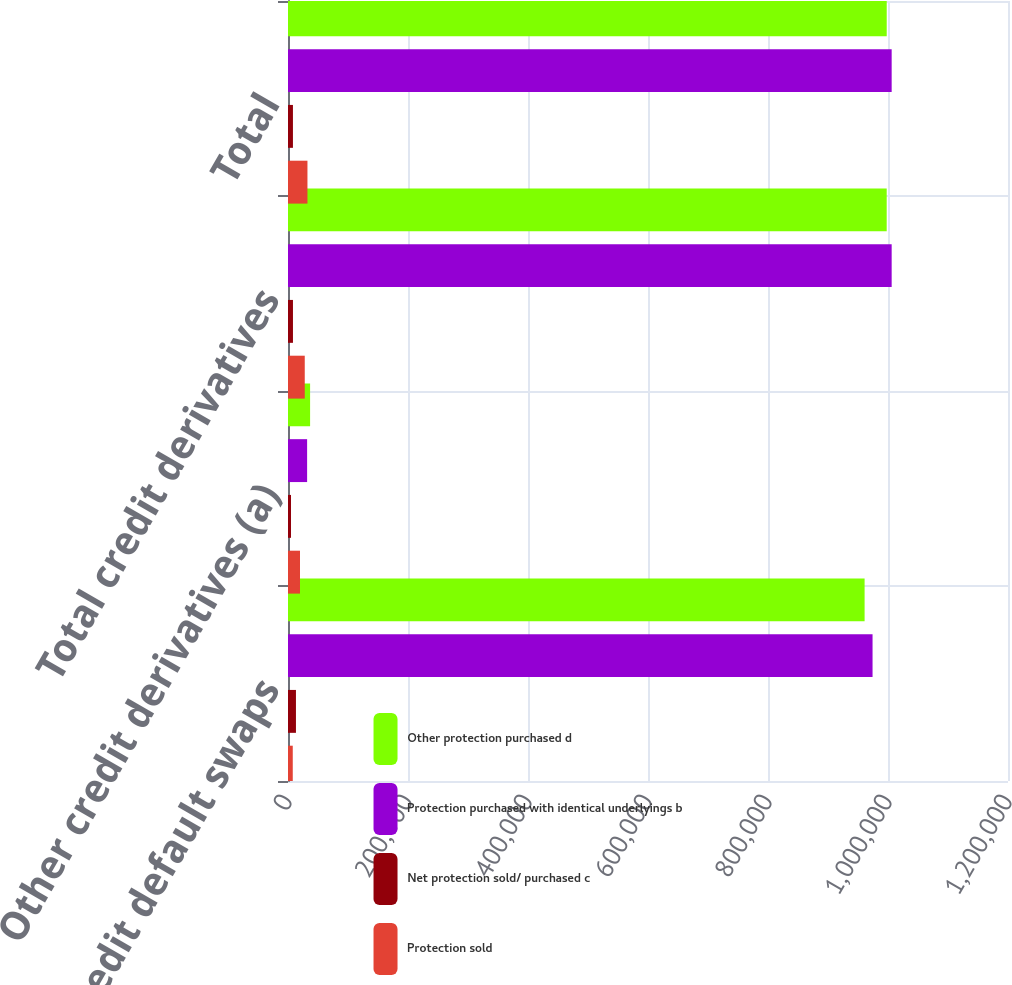<chart> <loc_0><loc_0><loc_500><loc_500><stacked_bar_chart><ecel><fcel>Credit default swaps<fcel>Other credit derivatives (a)<fcel>Total credit derivatives<fcel>Total<nl><fcel>Other protection purchased d<fcel>961003<fcel>36829<fcel>997832<fcel>997873<nl><fcel>Protection purchased with identical underlyings b<fcel>974252<fcel>31859<fcel>1.00611e+06<fcel>1.00611e+06<nl><fcel>Net protection sold/ purchased c<fcel>13249<fcel>4970<fcel>8279<fcel>8238<nl><fcel>Protection sold<fcel>7935<fcel>19991<fcel>27926<fcel>32431<nl></chart> 